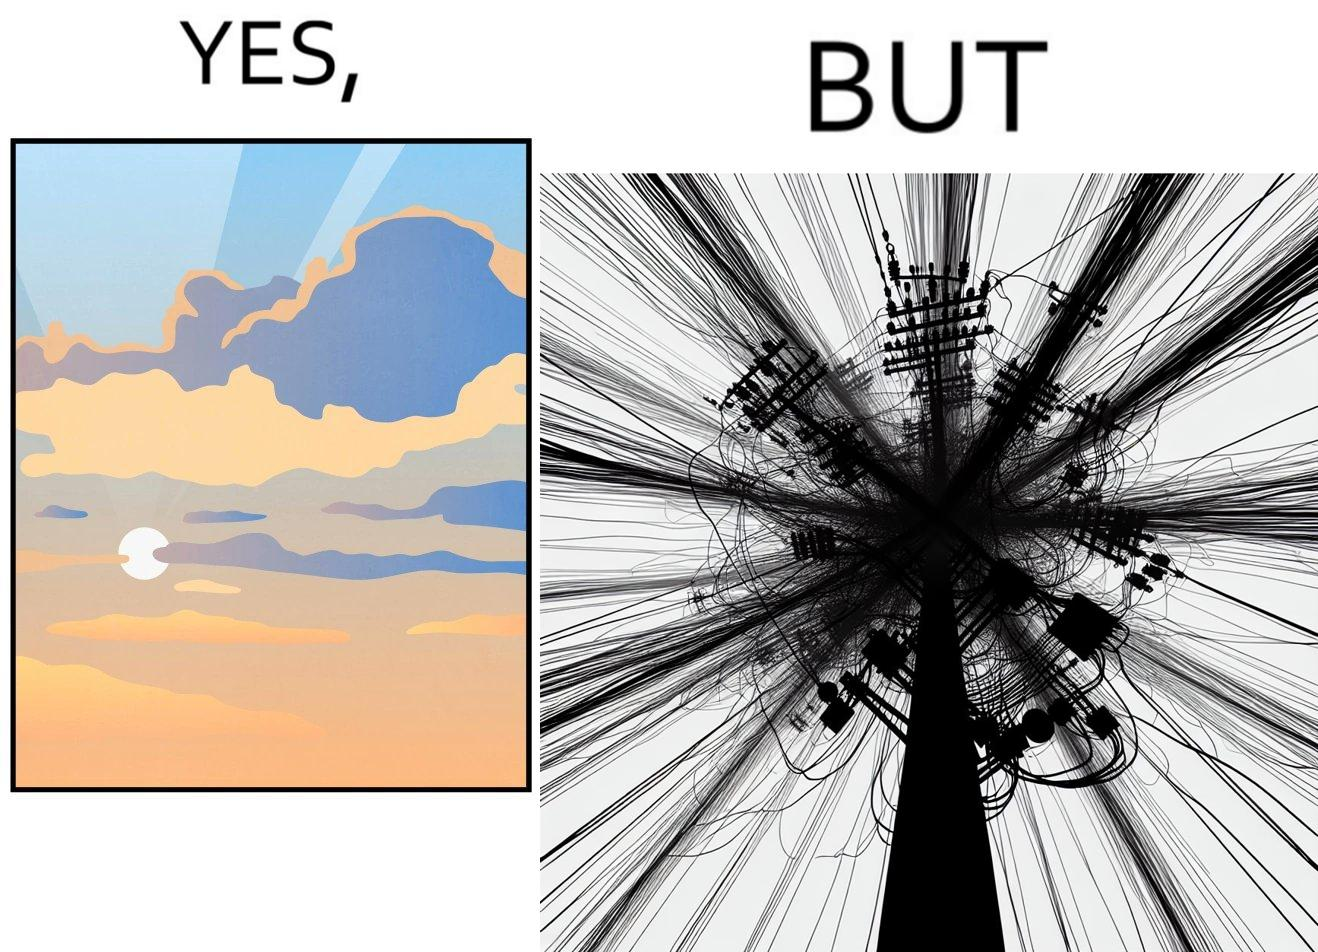Describe what you see in the left and right parts of this image. In the left part of the image: a clear sky with sun and clouds In the right part of the image: an electricity pole with a lot of wires over it 